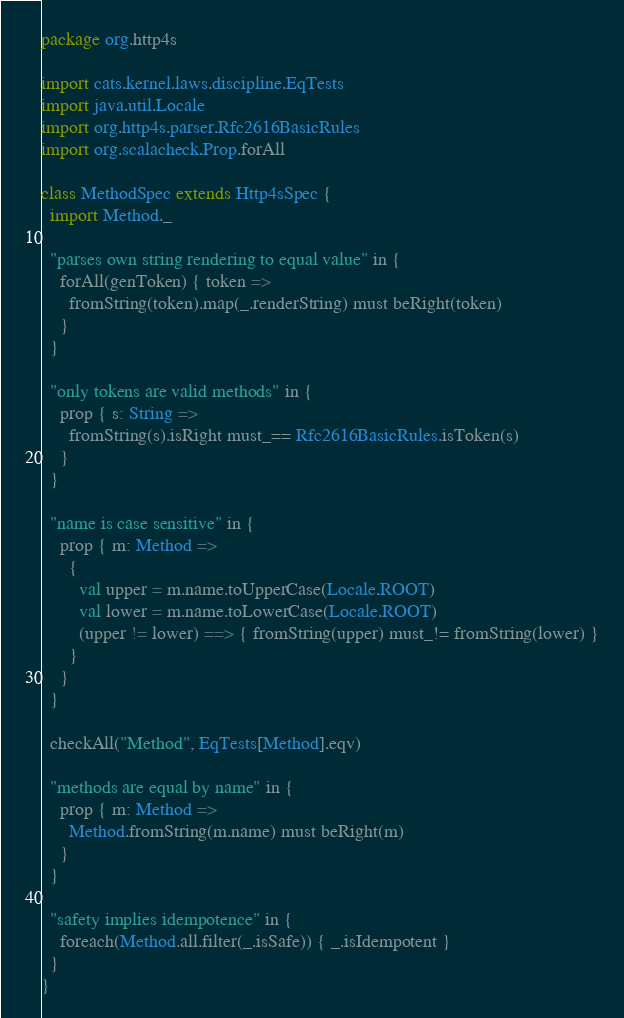<code> <loc_0><loc_0><loc_500><loc_500><_Scala_>package org.http4s

import cats.kernel.laws.discipline.EqTests
import java.util.Locale
import org.http4s.parser.Rfc2616BasicRules
import org.scalacheck.Prop.forAll

class MethodSpec extends Http4sSpec {
  import Method._

  "parses own string rendering to equal value" in {
    forAll(genToken) { token =>
      fromString(token).map(_.renderString) must beRight(token)
    }
  }

  "only tokens are valid methods" in {
    prop { s: String =>
      fromString(s).isRight must_== Rfc2616BasicRules.isToken(s)
    }
  }

  "name is case sensitive" in {
    prop { m: Method =>
      {
        val upper = m.name.toUpperCase(Locale.ROOT)
        val lower = m.name.toLowerCase(Locale.ROOT)
        (upper != lower) ==> { fromString(upper) must_!= fromString(lower) }
      }
    }
  }

  checkAll("Method", EqTests[Method].eqv)

  "methods are equal by name" in {
    prop { m: Method =>
      Method.fromString(m.name) must beRight(m)
    }
  }

  "safety implies idempotence" in {
    foreach(Method.all.filter(_.isSafe)) { _.isIdempotent }
  }
}
</code> 